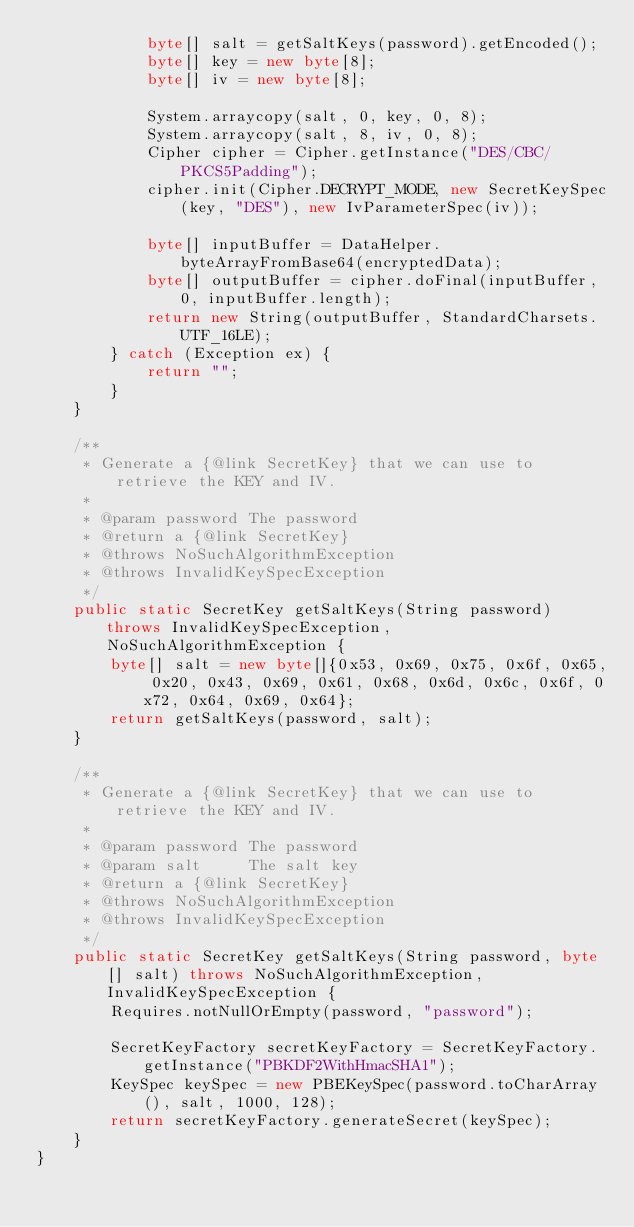Convert code to text. <code><loc_0><loc_0><loc_500><loc_500><_Java_>            byte[] salt = getSaltKeys(password).getEncoded();
            byte[] key = new byte[8];
            byte[] iv = new byte[8];

            System.arraycopy(salt, 0, key, 0, 8);
            System.arraycopy(salt, 8, iv, 0, 8);
            Cipher cipher = Cipher.getInstance("DES/CBC/PKCS5Padding");
            cipher.init(Cipher.DECRYPT_MODE, new SecretKeySpec(key, "DES"), new IvParameterSpec(iv));

            byte[] inputBuffer = DataHelper.byteArrayFromBase64(encryptedData);
            byte[] outputBuffer = cipher.doFinal(inputBuffer, 0, inputBuffer.length);
            return new String(outputBuffer, StandardCharsets.UTF_16LE);
        } catch (Exception ex) {
            return "";
        }
    }

    /**
     * Generate a {@link SecretKey} that we can use to retrieve the KEY and IV.
     *
     * @param password The password
     * @return a {@link SecretKey}
     * @throws NoSuchAlgorithmException
     * @throws InvalidKeySpecException
     */
    public static SecretKey getSaltKeys(String password) throws InvalidKeySpecException, NoSuchAlgorithmException {
        byte[] salt = new byte[]{0x53, 0x69, 0x75, 0x6f, 0x65, 0x20, 0x43, 0x69, 0x61, 0x68, 0x6d, 0x6c, 0x6f, 0x72, 0x64, 0x69, 0x64};
        return getSaltKeys(password, salt);
    }

    /**
     * Generate a {@link SecretKey} that we can use to retrieve the KEY and IV.
     *
     * @param password The password
     * @param salt     The salt key
     * @return a {@link SecretKey}
     * @throws NoSuchAlgorithmException
     * @throws InvalidKeySpecException
     */
    public static SecretKey getSaltKeys(String password, byte[] salt) throws NoSuchAlgorithmException, InvalidKeySpecException {
        Requires.notNullOrEmpty(password, "password");

        SecretKeyFactory secretKeyFactory = SecretKeyFactory.getInstance("PBKDF2WithHmacSHA1");
        KeySpec keySpec = new PBEKeySpec(password.toCharArray(), salt, 1000, 128);
        return secretKeyFactory.generateSecret(keySpec);
    }
}
</code> 